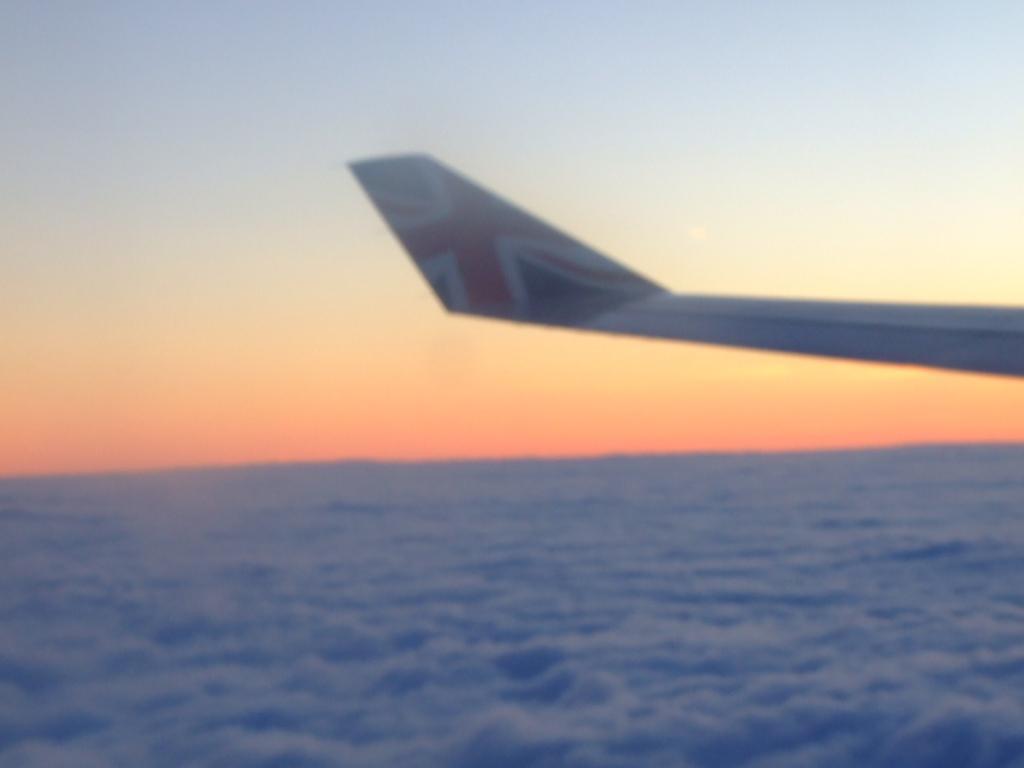How would you summarize this image in a sentence or two? In this image there is an airplane. At the bottom there is a water. And at the top there is a sky. 